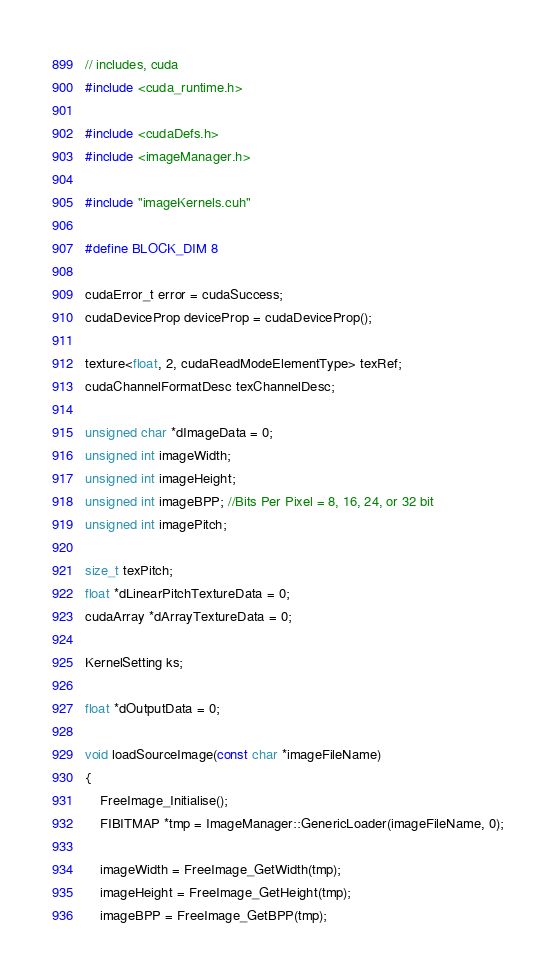Convert code to text. <code><loc_0><loc_0><loc_500><loc_500><_Cuda_>// includes, cuda
#include <cuda_runtime.h>

#include <cudaDefs.h>
#include <imageManager.h>

#include "imageKernels.cuh"

#define BLOCK_DIM 8

cudaError_t error = cudaSuccess;
cudaDeviceProp deviceProp = cudaDeviceProp();

texture<float, 2, cudaReadModeElementType> texRef;
cudaChannelFormatDesc texChannelDesc;

unsigned char *dImageData = 0;
unsigned int imageWidth;
unsigned int imageHeight;
unsigned int imageBPP; //Bits Per Pixel = 8, 16, 24, or 32 bit
unsigned int imagePitch;

size_t texPitch;
float *dLinearPitchTextureData = 0;
cudaArray *dArrayTextureData = 0;

KernelSetting ks;

float *dOutputData = 0;

void loadSourceImage(const char *imageFileName)
{
	FreeImage_Initialise();
	FIBITMAP *tmp = ImageManager::GenericLoader(imageFileName, 0);

	imageWidth = FreeImage_GetWidth(tmp);
	imageHeight = FreeImage_GetHeight(tmp);
	imageBPP = FreeImage_GetBPP(tmp);</code> 